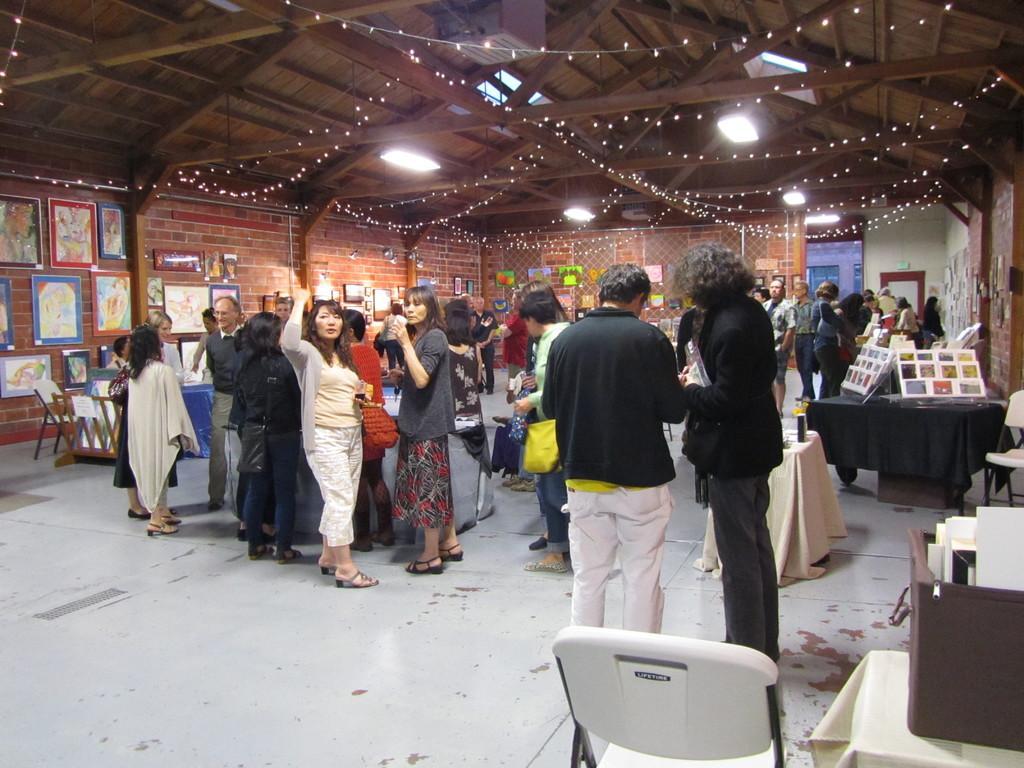Could you give a brief overview of what you see in this image? In this image there are a few people standing and sitting in chairs inside a hall, around them there are a few objects on the tables and there are empty chairs, the room is decorated with lights and there are some photo frames on the walls. 